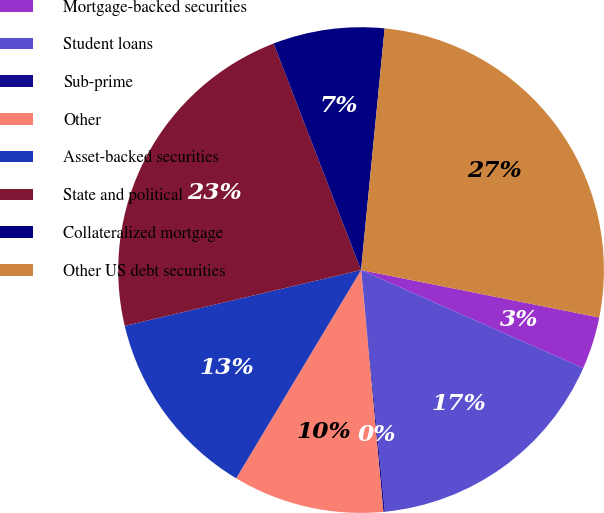Convert chart to OTSL. <chart><loc_0><loc_0><loc_500><loc_500><pie_chart><fcel>Mortgage-backed securities<fcel>Student loans<fcel>Sub-prime<fcel>Other<fcel>Asset-backed securities<fcel>State and political<fcel>Collateralized mortgage<fcel>Other US debt securities<nl><fcel>3.49%<fcel>16.82%<fcel>0.1%<fcel>10.06%<fcel>12.71%<fcel>22.83%<fcel>7.41%<fcel>26.58%<nl></chart> 